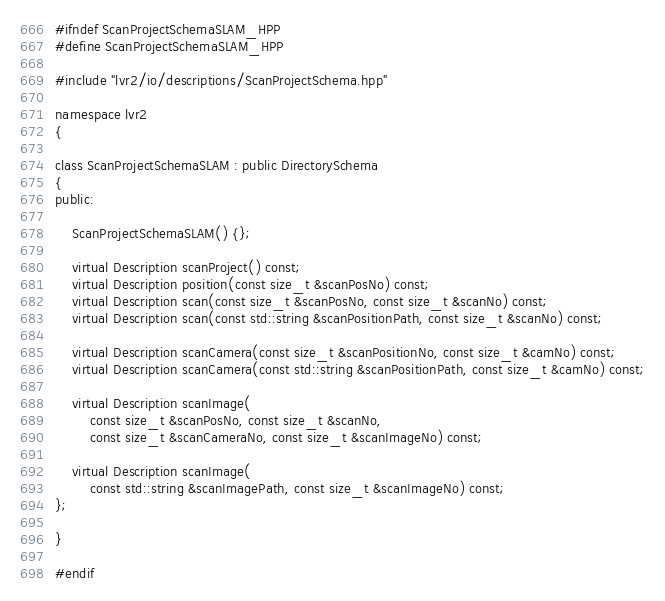Convert code to text. <code><loc_0><loc_0><loc_500><loc_500><_C++_>#ifndef ScanProjectSchemaSLAM_HPP
#define ScanProjectSchemaSLAM_HPP

#include "lvr2/io/descriptions/ScanProjectSchema.hpp"

namespace lvr2
{

class ScanProjectSchemaSLAM : public DirectorySchema
{
public:

    ScanProjectSchemaSLAM() {};

    virtual Description scanProject() const;
    virtual Description position(const size_t &scanPosNo) const;
    virtual Description scan(const size_t &scanPosNo, const size_t &scanNo) const;
    virtual Description scan(const std::string &scanPositionPath, const size_t &scanNo) const;

    virtual Description scanCamera(const size_t &scanPositionNo, const size_t &camNo) const;
    virtual Description scanCamera(const std::string &scanPositionPath, const size_t &camNo) const;

    virtual Description scanImage(
        const size_t &scanPosNo, const size_t &scanNo,
        const size_t &scanCameraNo, const size_t &scanImageNo) const;

    virtual Description scanImage(
        const std::string &scanImagePath, const size_t &scanImageNo) const;
};

}

#endif</code> 